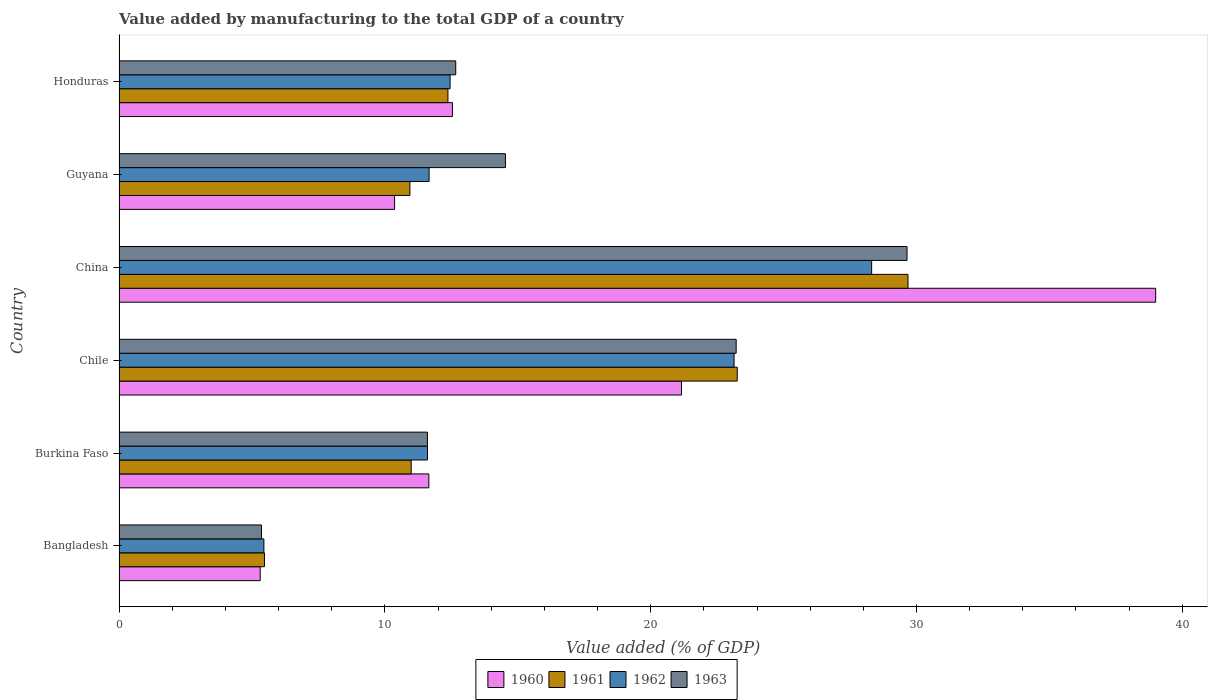How many different coloured bars are there?
Provide a succinct answer. 4. How many groups of bars are there?
Provide a short and direct response. 6. Are the number of bars per tick equal to the number of legend labels?
Offer a very short reply. Yes. Are the number of bars on each tick of the Y-axis equal?
Keep it short and to the point. Yes. How many bars are there on the 2nd tick from the top?
Give a very brief answer. 4. How many bars are there on the 2nd tick from the bottom?
Give a very brief answer. 4. What is the label of the 3rd group of bars from the top?
Offer a terse response. China. What is the value added by manufacturing to the total GDP in 1961 in Chile?
Provide a succinct answer. 23.26. Across all countries, what is the maximum value added by manufacturing to the total GDP in 1963?
Offer a very short reply. 29.64. Across all countries, what is the minimum value added by manufacturing to the total GDP in 1960?
Keep it short and to the point. 5.31. In which country was the value added by manufacturing to the total GDP in 1961 maximum?
Offer a terse response. China. What is the total value added by manufacturing to the total GDP in 1963 in the graph?
Your response must be concise. 97.02. What is the difference between the value added by manufacturing to the total GDP in 1960 in Burkina Faso and that in Chile?
Your response must be concise. -9.51. What is the difference between the value added by manufacturing to the total GDP in 1963 in Bangladesh and the value added by manufacturing to the total GDP in 1961 in China?
Offer a very short reply. -24.32. What is the average value added by manufacturing to the total GDP in 1963 per country?
Provide a succinct answer. 16.17. What is the difference between the value added by manufacturing to the total GDP in 1962 and value added by manufacturing to the total GDP in 1963 in Guyana?
Provide a short and direct response. -2.87. In how many countries, is the value added by manufacturing to the total GDP in 1961 greater than 24 %?
Ensure brevity in your answer.  1. What is the ratio of the value added by manufacturing to the total GDP in 1961 in China to that in Guyana?
Provide a short and direct response. 2.71. Is the value added by manufacturing to the total GDP in 1962 in Chile less than that in Guyana?
Offer a very short reply. No. Is the difference between the value added by manufacturing to the total GDP in 1962 in Guyana and Honduras greater than the difference between the value added by manufacturing to the total GDP in 1963 in Guyana and Honduras?
Keep it short and to the point. No. What is the difference between the highest and the second highest value added by manufacturing to the total GDP in 1963?
Your response must be concise. 6.43. What is the difference between the highest and the lowest value added by manufacturing to the total GDP in 1960?
Provide a succinct answer. 33.69. In how many countries, is the value added by manufacturing to the total GDP in 1963 greater than the average value added by manufacturing to the total GDP in 1963 taken over all countries?
Ensure brevity in your answer.  2. Is the sum of the value added by manufacturing to the total GDP in 1961 in Burkina Faso and Chile greater than the maximum value added by manufacturing to the total GDP in 1960 across all countries?
Provide a succinct answer. No. Is it the case that in every country, the sum of the value added by manufacturing to the total GDP in 1960 and value added by manufacturing to the total GDP in 1962 is greater than the sum of value added by manufacturing to the total GDP in 1963 and value added by manufacturing to the total GDP in 1961?
Keep it short and to the point. No. What does the 4th bar from the top in Bangladesh represents?
Offer a terse response. 1960. What does the 1st bar from the bottom in Bangladesh represents?
Provide a succinct answer. 1960. Is it the case that in every country, the sum of the value added by manufacturing to the total GDP in 1962 and value added by manufacturing to the total GDP in 1963 is greater than the value added by manufacturing to the total GDP in 1960?
Make the answer very short. Yes. How many bars are there?
Your response must be concise. 24. How many countries are there in the graph?
Make the answer very short. 6. What is the difference between two consecutive major ticks on the X-axis?
Provide a succinct answer. 10. Does the graph contain any zero values?
Ensure brevity in your answer.  No. Where does the legend appear in the graph?
Your answer should be very brief. Bottom center. What is the title of the graph?
Offer a terse response. Value added by manufacturing to the total GDP of a country. Does "1982" appear as one of the legend labels in the graph?
Your response must be concise. No. What is the label or title of the X-axis?
Make the answer very short. Value added (% of GDP). What is the label or title of the Y-axis?
Your answer should be very brief. Country. What is the Value added (% of GDP) of 1960 in Bangladesh?
Make the answer very short. 5.31. What is the Value added (% of GDP) in 1961 in Bangladesh?
Provide a short and direct response. 5.47. What is the Value added (% of GDP) in 1962 in Bangladesh?
Your answer should be compact. 5.45. What is the Value added (% of GDP) of 1963 in Bangladesh?
Give a very brief answer. 5.36. What is the Value added (% of GDP) in 1960 in Burkina Faso?
Keep it short and to the point. 11.65. What is the Value added (% of GDP) in 1961 in Burkina Faso?
Your response must be concise. 10.99. What is the Value added (% of GDP) of 1962 in Burkina Faso?
Make the answer very short. 11.6. What is the Value added (% of GDP) of 1963 in Burkina Faso?
Offer a terse response. 11.6. What is the Value added (% of GDP) in 1960 in Chile?
Ensure brevity in your answer.  21.16. What is the Value added (% of GDP) in 1961 in Chile?
Offer a terse response. 23.26. What is the Value added (% of GDP) in 1962 in Chile?
Make the answer very short. 23.14. What is the Value added (% of GDP) in 1963 in Chile?
Ensure brevity in your answer.  23.22. What is the Value added (% of GDP) in 1960 in China?
Give a very brief answer. 39. What is the Value added (% of GDP) of 1961 in China?
Provide a short and direct response. 29.68. What is the Value added (% of GDP) of 1962 in China?
Ensure brevity in your answer.  28.31. What is the Value added (% of GDP) in 1963 in China?
Ensure brevity in your answer.  29.64. What is the Value added (% of GDP) of 1960 in Guyana?
Make the answer very short. 10.37. What is the Value added (% of GDP) in 1961 in Guyana?
Ensure brevity in your answer.  10.94. What is the Value added (% of GDP) of 1962 in Guyana?
Keep it short and to the point. 11.66. What is the Value added (% of GDP) of 1963 in Guyana?
Keep it short and to the point. 14.54. What is the Value added (% of GDP) of 1960 in Honduras?
Your answer should be very brief. 12.54. What is the Value added (% of GDP) in 1961 in Honduras?
Your answer should be compact. 12.37. What is the Value added (% of GDP) of 1962 in Honduras?
Keep it short and to the point. 12.45. What is the Value added (% of GDP) of 1963 in Honduras?
Provide a short and direct response. 12.67. Across all countries, what is the maximum Value added (% of GDP) in 1960?
Offer a terse response. 39. Across all countries, what is the maximum Value added (% of GDP) of 1961?
Your response must be concise. 29.68. Across all countries, what is the maximum Value added (% of GDP) of 1962?
Keep it short and to the point. 28.31. Across all countries, what is the maximum Value added (% of GDP) in 1963?
Give a very brief answer. 29.64. Across all countries, what is the minimum Value added (% of GDP) of 1960?
Provide a short and direct response. 5.31. Across all countries, what is the minimum Value added (% of GDP) of 1961?
Offer a very short reply. 5.47. Across all countries, what is the minimum Value added (% of GDP) of 1962?
Offer a terse response. 5.45. Across all countries, what is the minimum Value added (% of GDP) of 1963?
Keep it short and to the point. 5.36. What is the total Value added (% of GDP) in 1960 in the graph?
Provide a short and direct response. 100.03. What is the total Value added (% of GDP) of 1961 in the graph?
Provide a succinct answer. 92.71. What is the total Value added (% of GDP) in 1962 in the graph?
Ensure brevity in your answer.  92.62. What is the total Value added (% of GDP) in 1963 in the graph?
Offer a terse response. 97.02. What is the difference between the Value added (% of GDP) in 1960 in Bangladesh and that in Burkina Faso?
Give a very brief answer. -6.34. What is the difference between the Value added (% of GDP) of 1961 in Bangladesh and that in Burkina Faso?
Your answer should be very brief. -5.52. What is the difference between the Value added (% of GDP) in 1962 in Bangladesh and that in Burkina Faso?
Provide a short and direct response. -6.16. What is the difference between the Value added (% of GDP) in 1963 in Bangladesh and that in Burkina Faso?
Make the answer very short. -6.24. What is the difference between the Value added (% of GDP) of 1960 in Bangladesh and that in Chile?
Offer a terse response. -15.85. What is the difference between the Value added (% of GDP) in 1961 in Bangladesh and that in Chile?
Provide a succinct answer. -17.79. What is the difference between the Value added (% of GDP) in 1962 in Bangladesh and that in Chile?
Ensure brevity in your answer.  -17.69. What is the difference between the Value added (% of GDP) of 1963 in Bangladesh and that in Chile?
Your answer should be compact. -17.86. What is the difference between the Value added (% of GDP) in 1960 in Bangladesh and that in China?
Your response must be concise. -33.69. What is the difference between the Value added (% of GDP) in 1961 in Bangladesh and that in China?
Offer a very short reply. -24.21. What is the difference between the Value added (% of GDP) of 1962 in Bangladesh and that in China?
Offer a terse response. -22.86. What is the difference between the Value added (% of GDP) in 1963 in Bangladesh and that in China?
Keep it short and to the point. -24.28. What is the difference between the Value added (% of GDP) in 1960 in Bangladesh and that in Guyana?
Make the answer very short. -5.06. What is the difference between the Value added (% of GDP) of 1961 in Bangladesh and that in Guyana?
Give a very brief answer. -5.47. What is the difference between the Value added (% of GDP) of 1962 in Bangladesh and that in Guyana?
Offer a terse response. -6.22. What is the difference between the Value added (% of GDP) of 1963 in Bangladesh and that in Guyana?
Provide a succinct answer. -9.18. What is the difference between the Value added (% of GDP) in 1960 in Bangladesh and that in Honduras?
Keep it short and to the point. -7.23. What is the difference between the Value added (% of GDP) of 1961 in Bangladesh and that in Honduras?
Make the answer very short. -6.9. What is the difference between the Value added (% of GDP) of 1962 in Bangladesh and that in Honduras?
Make the answer very short. -7.01. What is the difference between the Value added (% of GDP) of 1963 in Bangladesh and that in Honduras?
Your response must be concise. -7.31. What is the difference between the Value added (% of GDP) in 1960 in Burkina Faso and that in Chile?
Offer a terse response. -9.51. What is the difference between the Value added (% of GDP) of 1961 in Burkina Faso and that in Chile?
Your answer should be very brief. -12.27. What is the difference between the Value added (% of GDP) of 1962 in Burkina Faso and that in Chile?
Your response must be concise. -11.53. What is the difference between the Value added (% of GDP) in 1963 in Burkina Faso and that in Chile?
Your answer should be compact. -11.62. What is the difference between the Value added (% of GDP) of 1960 in Burkina Faso and that in China?
Give a very brief answer. -27.34. What is the difference between the Value added (% of GDP) in 1961 in Burkina Faso and that in China?
Keep it short and to the point. -18.69. What is the difference between the Value added (% of GDP) in 1962 in Burkina Faso and that in China?
Offer a very short reply. -16.71. What is the difference between the Value added (% of GDP) of 1963 in Burkina Faso and that in China?
Your answer should be very brief. -18.04. What is the difference between the Value added (% of GDP) of 1960 in Burkina Faso and that in Guyana?
Offer a terse response. 1.29. What is the difference between the Value added (% of GDP) of 1961 in Burkina Faso and that in Guyana?
Your answer should be very brief. 0.05. What is the difference between the Value added (% of GDP) of 1962 in Burkina Faso and that in Guyana?
Your response must be concise. -0.06. What is the difference between the Value added (% of GDP) of 1963 in Burkina Faso and that in Guyana?
Give a very brief answer. -2.94. What is the difference between the Value added (% of GDP) in 1960 in Burkina Faso and that in Honduras?
Offer a terse response. -0.89. What is the difference between the Value added (% of GDP) in 1961 in Burkina Faso and that in Honduras?
Your answer should be very brief. -1.38. What is the difference between the Value added (% of GDP) of 1962 in Burkina Faso and that in Honduras?
Keep it short and to the point. -0.85. What is the difference between the Value added (% of GDP) in 1963 in Burkina Faso and that in Honduras?
Make the answer very short. -1.07. What is the difference between the Value added (% of GDP) of 1960 in Chile and that in China?
Offer a very short reply. -17.84. What is the difference between the Value added (% of GDP) of 1961 in Chile and that in China?
Offer a terse response. -6.42. What is the difference between the Value added (% of GDP) in 1962 in Chile and that in China?
Provide a succinct answer. -5.17. What is the difference between the Value added (% of GDP) in 1963 in Chile and that in China?
Offer a very short reply. -6.43. What is the difference between the Value added (% of GDP) in 1960 in Chile and that in Guyana?
Give a very brief answer. 10.79. What is the difference between the Value added (% of GDP) in 1961 in Chile and that in Guyana?
Ensure brevity in your answer.  12.32. What is the difference between the Value added (% of GDP) of 1962 in Chile and that in Guyana?
Your answer should be compact. 11.47. What is the difference between the Value added (% of GDP) in 1963 in Chile and that in Guyana?
Provide a short and direct response. 8.68. What is the difference between the Value added (% of GDP) in 1960 in Chile and that in Honduras?
Provide a short and direct response. 8.62. What is the difference between the Value added (% of GDP) in 1961 in Chile and that in Honduras?
Give a very brief answer. 10.88. What is the difference between the Value added (% of GDP) in 1962 in Chile and that in Honduras?
Your response must be concise. 10.68. What is the difference between the Value added (% of GDP) in 1963 in Chile and that in Honduras?
Ensure brevity in your answer.  10.55. What is the difference between the Value added (% of GDP) in 1960 in China and that in Guyana?
Provide a succinct answer. 28.63. What is the difference between the Value added (% of GDP) of 1961 in China and that in Guyana?
Offer a terse response. 18.74. What is the difference between the Value added (% of GDP) in 1962 in China and that in Guyana?
Provide a short and direct response. 16.65. What is the difference between the Value added (% of GDP) in 1963 in China and that in Guyana?
Provide a succinct answer. 15.11. What is the difference between the Value added (% of GDP) in 1960 in China and that in Honduras?
Make the answer very short. 26.46. What is the difference between the Value added (% of GDP) in 1961 in China and that in Honduras?
Your response must be concise. 17.31. What is the difference between the Value added (% of GDP) in 1962 in China and that in Honduras?
Provide a succinct answer. 15.86. What is the difference between the Value added (% of GDP) of 1963 in China and that in Honduras?
Offer a very short reply. 16.98. What is the difference between the Value added (% of GDP) in 1960 in Guyana and that in Honduras?
Provide a short and direct response. -2.18. What is the difference between the Value added (% of GDP) in 1961 in Guyana and that in Honduras?
Your answer should be compact. -1.43. What is the difference between the Value added (% of GDP) in 1962 in Guyana and that in Honduras?
Your answer should be very brief. -0.79. What is the difference between the Value added (% of GDP) of 1963 in Guyana and that in Honduras?
Offer a very short reply. 1.87. What is the difference between the Value added (% of GDP) of 1960 in Bangladesh and the Value added (% of GDP) of 1961 in Burkina Faso?
Ensure brevity in your answer.  -5.68. What is the difference between the Value added (% of GDP) in 1960 in Bangladesh and the Value added (% of GDP) in 1962 in Burkina Faso?
Make the answer very short. -6.29. What is the difference between the Value added (% of GDP) of 1960 in Bangladesh and the Value added (% of GDP) of 1963 in Burkina Faso?
Ensure brevity in your answer.  -6.29. What is the difference between the Value added (% of GDP) of 1961 in Bangladesh and the Value added (% of GDP) of 1962 in Burkina Faso?
Provide a short and direct response. -6.13. What is the difference between the Value added (% of GDP) in 1961 in Bangladesh and the Value added (% of GDP) in 1963 in Burkina Faso?
Make the answer very short. -6.13. What is the difference between the Value added (% of GDP) in 1962 in Bangladesh and the Value added (% of GDP) in 1963 in Burkina Faso?
Provide a succinct answer. -6.15. What is the difference between the Value added (% of GDP) of 1960 in Bangladesh and the Value added (% of GDP) of 1961 in Chile?
Your answer should be very brief. -17.95. What is the difference between the Value added (% of GDP) of 1960 in Bangladesh and the Value added (% of GDP) of 1962 in Chile?
Provide a short and direct response. -17.83. What is the difference between the Value added (% of GDP) of 1960 in Bangladesh and the Value added (% of GDP) of 1963 in Chile?
Give a very brief answer. -17.91. What is the difference between the Value added (% of GDP) in 1961 in Bangladesh and the Value added (% of GDP) in 1962 in Chile?
Your answer should be compact. -17.67. What is the difference between the Value added (% of GDP) of 1961 in Bangladesh and the Value added (% of GDP) of 1963 in Chile?
Make the answer very short. -17.75. What is the difference between the Value added (% of GDP) in 1962 in Bangladesh and the Value added (% of GDP) in 1963 in Chile?
Ensure brevity in your answer.  -17.77. What is the difference between the Value added (% of GDP) in 1960 in Bangladesh and the Value added (% of GDP) in 1961 in China?
Provide a short and direct response. -24.37. What is the difference between the Value added (% of GDP) in 1960 in Bangladesh and the Value added (% of GDP) in 1962 in China?
Keep it short and to the point. -23. What is the difference between the Value added (% of GDP) of 1960 in Bangladesh and the Value added (% of GDP) of 1963 in China?
Offer a terse response. -24.33. What is the difference between the Value added (% of GDP) of 1961 in Bangladesh and the Value added (% of GDP) of 1962 in China?
Keep it short and to the point. -22.84. What is the difference between the Value added (% of GDP) of 1961 in Bangladesh and the Value added (% of GDP) of 1963 in China?
Ensure brevity in your answer.  -24.17. What is the difference between the Value added (% of GDP) of 1962 in Bangladesh and the Value added (% of GDP) of 1963 in China?
Your response must be concise. -24.2. What is the difference between the Value added (% of GDP) in 1960 in Bangladesh and the Value added (% of GDP) in 1961 in Guyana?
Ensure brevity in your answer.  -5.63. What is the difference between the Value added (% of GDP) of 1960 in Bangladesh and the Value added (% of GDP) of 1962 in Guyana?
Offer a very short reply. -6.35. What is the difference between the Value added (% of GDP) in 1960 in Bangladesh and the Value added (% of GDP) in 1963 in Guyana?
Provide a succinct answer. -9.23. What is the difference between the Value added (% of GDP) in 1961 in Bangladesh and the Value added (% of GDP) in 1962 in Guyana?
Provide a short and direct response. -6.19. What is the difference between the Value added (% of GDP) in 1961 in Bangladesh and the Value added (% of GDP) in 1963 in Guyana?
Your answer should be very brief. -9.07. What is the difference between the Value added (% of GDP) of 1962 in Bangladesh and the Value added (% of GDP) of 1963 in Guyana?
Give a very brief answer. -9.09. What is the difference between the Value added (% of GDP) in 1960 in Bangladesh and the Value added (% of GDP) in 1961 in Honduras?
Keep it short and to the point. -7.06. What is the difference between the Value added (% of GDP) in 1960 in Bangladesh and the Value added (% of GDP) in 1962 in Honduras?
Your response must be concise. -7.14. What is the difference between the Value added (% of GDP) in 1960 in Bangladesh and the Value added (% of GDP) in 1963 in Honduras?
Your answer should be very brief. -7.36. What is the difference between the Value added (% of GDP) in 1961 in Bangladesh and the Value added (% of GDP) in 1962 in Honduras?
Ensure brevity in your answer.  -6.98. What is the difference between the Value added (% of GDP) of 1961 in Bangladesh and the Value added (% of GDP) of 1963 in Honduras?
Your answer should be compact. -7.2. What is the difference between the Value added (% of GDP) of 1962 in Bangladesh and the Value added (% of GDP) of 1963 in Honduras?
Make the answer very short. -7.22. What is the difference between the Value added (% of GDP) of 1960 in Burkina Faso and the Value added (% of GDP) of 1961 in Chile?
Give a very brief answer. -11.6. What is the difference between the Value added (% of GDP) of 1960 in Burkina Faso and the Value added (% of GDP) of 1962 in Chile?
Your answer should be compact. -11.48. What is the difference between the Value added (% of GDP) of 1960 in Burkina Faso and the Value added (% of GDP) of 1963 in Chile?
Provide a short and direct response. -11.56. What is the difference between the Value added (% of GDP) in 1961 in Burkina Faso and the Value added (% of GDP) in 1962 in Chile?
Your answer should be very brief. -12.15. What is the difference between the Value added (% of GDP) of 1961 in Burkina Faso and the Value added (% of GDP) of 1963 in Chile?
Offer a terse response. -12.23. What is the difference between the Value added (% of GDP) of 1962 in Burkina Faso and the Value added (% of GDP) of 1963 in Chile?
Give a very brief answer. -11.61. What is the difference between the Value added (% of GDP) of 1960 in Burkina Faso and the Value added (% of GDP) of 1961 in China?
Make the answer very short. -18.03. What is the difference between the Value added (% of GDP) in 1960 in Burkina Faso and the Value added (% of GDP) in 1962 in China?
Provide a short and direct response. -16.66. What is the difference between the Value added (% of GDP) in 1960 in Burkina Faso and the Value added (% of GDP) in 1963 in China?
Your answer should be compact. -17.99. What is the difference between the Value added (% of GDP) in 1961 in Burkina Faso and the Value added (% of GDP) in 1962 in China?
Provide a succinct answer. -17.32. What is the difference between the Value added (% of GDP) in 1961 in Burkina Faso and the Value added (% of GDP) in 1963 in China?
Provide a short and direct response. -18.65. What is the difference between the Value added (% of GDP) in 1962 in Burkina Faso and the Value added (% of GDP) in 1963 in China?
Offer a terse response. -18.04. What is the difference between the Value added (% of GDP) of 1960 in Burkina Faso and the Value added (% of GDP) of 1961 in Guyana?
Offer a terse response. 0.71. What is the difference between the Value added (% of GDP) of 1960 in Burkina Faso and the Value added (% of GDP) of 1962 in Guyana?
Provide a succinct answer. -0.01. What is the difference between the Value added (% of GDP) in 1960 in Burkina Faso and the Value added (% of GDP) in 1963 in Guyana?
Make the answer very short. -2.88. What is the difference between the Value added (% of GDP) of 1961 in Burkina Faso and the Value added (% of GDP) of 1962 in Guyana?
Offer a terse response. -0.67. What is the difference between the Value added (% of GDP) in 1961 in Burkina Faso and the Value added (% of GDP) in 1963 in Guyana?
Provide a short and direct response. -3.55. What is the difference between the Value added (% of GDP) of 1962 in Burkina Faso and the Value added (% of GDP) of 1963 in Guyana?
Make the answer very short. -2.93. What is the difference between the Value added (% of GDP) of 1960 in Burkina Faso and the Value added (% of GDP) of 1961 in Honduras?
Give a very brief answer. -0.72. What is the difference between the Value added (% of GDP) of 1960 in Burkina Faso and the Value added (% of GDP) of 1962 in Honduras?
Your answer should be very brief. -0.8. What is the difference between the Value added (% of GDP) of 1960 in Burkina Faso and the Value added (% of GDP) of 1963 in Honduras?
Your response must be concise. -1.01. What is the difference between the Value added (% of GDP) in 1961 in Burkina Faso and the Value added (% of GDP) in 1962 in Honduras?
Offer a very short reply. -1.46. What is the difference between the Value added (% of GDP) in 1961 in Burkina Faso and the Value added (% of GDP) in 1963 in Honduras?
Make the answer very short. -1.68. What is the difference between the Value added (% of GDP) in 1962 in Burkina Faso and the Value added (% of GDP) in 1963 in Honduras?
Keep it short and to the point. -1.06. What is the difference between the Value added (% of GDP) of 1960 in Chile and the Value added (% of GDP) of 1961 in China?
Provide a succinct answer. -8.52. What is the difference between the Value added (% of GDP) of 1960 in Chile and the Value added (% of GDP) of 1962 in China?
Provide a short and direct response. -7.15. What is the difference between the Value added (% of GDP) in 1960 in Chile and the Value added (% of GDP) in 1963 in China?
Your answer should be compact. -8.48. What is the difference between the Value added (% of GDP) in 1961 in Chile and the Value added (% of GDP) in 1962 in China?
Provide a succinct answer. -5.06. What is the difference between the Value added (% of GDP) of 1961 in Chile and the Value added (% of GDP) of 1963 in China?
Offer a terse response. -6.39. What is the difference between the Value added (% of GDP) of 1962 in Chile and the Value added (% of GDP) of 1963 in China?
Your response must be concise. -6.51. What is the difference between the Value added (% of GDP) of 1960 in Chile and the Value added (% of GDP) of 1961 in Guyana?
Make the answer very short. 10.22. What is the difference between the Value added (% of GDP) in 1960 in Chile and the Value added (% of GDP) in 1962 in Guyana?
Your response must be concise. 9.5. What is the difference between the Value added (% of GDP) in 1960 in Chile and the Value added (% of GDP) in 1963 in Guyana?
Keep it short and to the point. 6.62. What is the difference between the Value added (% of GDP) of 1961 in Chile and the Value added (% of GDP) of 1962 in Guyana?
Keep it short and to the point. 11.59. What is the difference between the Value added (% of GDP) in 1961 in Chile and the Value added (% of GDP) in 1963 in Guyana?
Provide a short and direct response. 8.72. What is the difference between the Value added (% of GDP) in 1962 in Chile and the Value added (% of GDP) in 1963 in Guyana?
Offer a terse response. 8.6. What is the difference between the Value added (% of GDP) of 1960 in Chile and the Value added (% of GDP) of 1961 in Honduras?
Ensure brevity in your answer.  8.79. What is the difference between the Value added (% of GDP) in 1960 in Chile and the Value added (% of GDP) in 1962 in Honduras?
Your answer should be compact. 8.71. What is the difference between the Value added (% of GDP) in 1960 in Chile and the Value added (% of GDP) in 1963 in Honduras?
Make the answer very short. 8.49. What is the difference between the Value added (% of GDP) in 1961 in Chile and the Value added (% of GDP) in 1962 in Honduras?
Keep it short and to the point. 10.8. What is the difference between the Value added (% of GDP) in 1961 in Chile and the Value added (% of GDP) in 1963 in Honduras?
Make the answer very short. 10.59. What is the difference between the Value added (% of GDP) in 1962 in Chile and the Value added (% of GDP) in 1963 in Honduras?
Your answer should be very brief. 10.47. What is the difference between the Value added (% of GDP) of 1960 in China and the Value added (% of GDP) of 1961 in Guyana?
Your answer should be compact. 28.06. What is the difference between the Value added (% of GDP) of 1960 in China and the Value added (% of GDP) of 1962 in Guyana?
Ensure brevity in your answer.  27.33. What is the difference between the Value added (% of GDP) of 1960 in China and the Value added (% of GDP) of 1963 in Guyana?
Make the answer very short. 24.46. What is the difference between the Value added (% of GDP) in 1961 in China and the Value added (% of GDP) in 1962 in Guyana?
Your response must be concise. 18.02. What is the difference between the Value added (% of GDP) of 1961 in China and the Value added (% of GDP) of 1963 in Guyana?
Provide a succinct answer. 15.14. What is the difference between the Value added (% of GDP) of 1962 in China and the Value added (% of GDP) of 1963 in Guyana?
Your response must be concise. 13.78. What is the difference between the Value added (% of GDP) in 1960 in China and the Value added (% of GDP) in 1961 in Honduras?
Make the answer very short. 26.63. What is the difference between the Value added (% of GDP) in 1960 in China and the Value added (% of GDP) in 1962 in Honduras?
Keep it short and to the point. 26.54. What is the difference between the Value added (% of GDP) of 1960 in China and the Value added (% of GDP) of 1963 in Honduras?
Offer a very short reply. 26.33. What is the difference between the Value added (% of GDP) in 1961 in China and the Value added (% of GDP) in 1962 in Honduras?
Make the answer very short. 17.23. What is the difference between the Value added (% of GDP) of 1961 in China and the Value added (% of GDP) of 1963 in Honduras?
Your answer should be very brief. 17.01. What is the difference between the Value added (% of GDP) of 1962 in China and the Value added (% of GDP) of 1963 in Honduras?
Your answer should be compact. 15.65. What is the difference between the Value added (% of GDP) in 1960 in Guyana and the Value added (% of GDP) in 1961 in Honduras?
Provide a short and direct response. -2.01. What is the difference between the Value added (% of GDP) of 1960 in Guyana and the Value added (% of GDP) of 1962 in Honduras?
Your answer should be very brief. -2.09. What is the difference between the Value added (% of GDP) of 1960 in Guyana and the Value added (% of GDP) of 1963 in Honduras?
Provide a succinct answer. -2.3. What is the difference between the Value added (% of GDP) in 1961 in Guyana and the Value added (% of GDP) in 1962 in Honduras?
Provide a succinct answer. -1.51. What is the difference between the Value added (% of GDP) of 1961 in Guyana and the Value added (% of GDP) of 1963 in Honduras?
Your response must be concise. -1.73. What is the difference between the Value added (% of GDP) in 1962 in Guyana and the Value added (% of GDP) in 1963 in Honduras?
Your answer should be compact. -1. What is the average Value added (% of GDP) in 1960 per country?
Give a very brief answer. 16.67. What is the average Value added (% of GDP) of 1961 per country?
Your answer should be compact. 15.45. What is the average Value added (% of GDP) of 1962 per country?
Give a very brief answer. 15.44. What is the average Value added (% of GDP) in 1963 per country?
Offer a very short reply. 16.17. What is the difference between the Value added (% of GDP) of 1960 and Value added (% of GDP) of 1961 in Bangladesh?
Keep it short and to the point. -0.16. What is the difference between the Value added (% of GDP) in 1960 and Value added (% of GDP) in 1962 in Bangladesh?
Offer a terse response. -0.14. What is the difference between the Value added (% of GDP) of 1960 and Value added (% of GDP) of 1963 in Bangladesh?
Provide a succinct answer. -0.05. What is the difference between the Value added (% of GDP) of 1961 and Value added (% of GDP) of 1962 in Bangladesh?
Offer a very short reply. 0.02. What is the difference between the Value added (% of GDP) in 1961 and Value added (% of GDP) in 1963 in Bangladesh?
Provide a short and direct response. 0.11. What is the difference between the Value added (% of GDP) in 1962 and Value added (% of GDP) in 1963 in Bangladesh?
Ensure brevity in your answer.  0.09. What is the difference between the Value added (% of GDP) of 1960 and Value added (% of GDP) of 1961 in Burkina Faso?
Make the answer very short. 0.66. What is the difference between the Value added (% of GDP) in 1960 and Value added (% of GDP) in 1962 in Burkina Faso?
Offer a terse response. 0.05. What is the difference between the Value added (% of GDP) of 1960 and Value added (% of GDP) of 1963 in Burkina Faso?
Your answer should be very brief. 0.05. What is the difference between the Value added (% of GDP) in 1961 and Value added (% of GDP) in 1962 in Burkina Faso?
Your response must be concise. -0.61. What is the difference between the Value added (% of GDP) of 1961 and Value added (% of GDP) of 1963 in Burkina Faso?
Offer a terse response. -0.61. What is the difference between the Value added (% of GDP) in 1962 and Value added (% of GDP) in 1963 in Burkina Faso?
Offer a terse response. 0. What is the difference between the Value added (% of GDP) in 1960 and Value added (% of GDP) in 1961 in Chile?
Provide a short and direct response. -2.1. What is the difference between the Value added (% of GDP) in 1960 and Value added (% of GDP) in 1962 in Chile?
Offer a terse response. -1.98. What is the difference between the Value added (% of GDP) in 1960 and Value added (% of GDP) in 1963 in Chile?
Your answer should be compact. -2.06. What is the difference between the Value added (% of GDP) of 1961 and Value added (% of GDP) of 1962 in Chile?
Your answer should be compact. 0.12. What is the difference between the Value added (% of GDP) in 1961 and Value added (% of GDP) in 1963 in Chile?
Offer a terse response. 0.04. What is the difference between the Value added (% of GDP) in 1962 and Value added (% of GDP) in 1963 in Chile?
Give a very brief answer. -0.08. What is the difference between the Value added (% of GDP) of 1960 and Value added (% of GDP) of 1961 in China?
Keep it short and to the point. 9.32. What is the difference between the Value added (% of GDP) of 1960 and Value added (% of GDP) of 1962 in China?
Your answer should be very brief. 10.69. What is the difference between the Value added (% of GDP) in 1960 and Value added (% of GDP) in 1963 in China?
Keep it short and to the point. 9.35. What is the difference between the Value added (% of GDP) of 1961 and Value added (% of GDP) of 1962 in China?
Provide a short and direct response. 1.37. What is the difference between the Value added (% of GDP) in 1961 and Value added (% of GDP) in 1963 in China?
Make the answer very short. 0.04. What is the difference between the Value added (% of GDP) in 1962 and Value added (% of GDP) in 1963 in China?
Offer a very short reply. -1.33. What is the difference between the Value added (% of GDP) in 1960 and Value added (% of GDP) in 1961 in Guyana?
Your answer should be compact. -0.58. What is the difference between the Value added (% of GDP) of 1960 and Value added (% of GDP) of 1962 in Guyana?
Provide a succinct answer. -1.3. What is the difference between the Value added (% of GDP) of 1960 and Value added (% of GDP) of 1963 in Guyana?
Give a very brief answer. -4.17. What is the difference between the Value added (% of GDP) of 1961 and Value added (% of GDP) of 1962 in Guyana?
Your response must be concise. -0.72. What is the difference between the Value added (% of GDP) in 1961 and Value added (% of GDP) in 1963 in Guyana?
Ensure brevity in your answer.  -3.6. What is the difference between the Value added (% of GDP) in 1962 and Value added (% of GDP) in 1963 in Guyana?
Provide a short and direct response. -2.87. What is the difference between the Value added (% of GDP) of 1960 and Value added (% of GDP) of 1961 in Honduras?
Offer a terse response. 0.17. What is the difference between the Value added (% of GDP) of 1960 and Value added (% of GDP) of 1962 in Honduras?
Your answer should be very brief. 0.09. What is the difference between the Value added (% of GDP) in 1960 and Value added (% of GDP) in 1963 in Honduras?
Your response must be concise. -0.13. What is the difference between the Value added (% of GDP) in 1961 and Value added (% of GDP) in 1962 in Honduras?
Keep it short and to the point. -0.08. What is the difference between the Value added (% of GDP) in 1961 and Value added (% of GDP) in 1963 in Honduras?
Your answer should be very brief. -0.29. What is the difference between the Value added (% of GDP) of 1962 and Value added (% of GDP) of 1963 in Honduras?
Provide a short and direct response. -0.21. What is the ratio of the Value added (% of GDP) of 1960 in Bangladesh to that in Burkina Faso?
Ensure brevity in your answer.  0.46. What is the ratio of the Value added (% of GDP) of 1961 in Bangladesh to that in Burkina Faso?
Offer a terse response. 0.5. What is the ratio of the Value added (% of GDP) of 1962 in Bangladesh to that in Burkina Faso?
Provide a short and direct response. 0.47. What is the ratio of the Value added (% of GDP) in 1963 in Bangladesh to that in Burkina Faso?
Your answer should be very brief. 0.46. What is the ratio of the Value added (% of GDP) in 1960 in Bangladesh to that in Chile?
Your response must be concise. 0.25. What is the ratio of the Value added (% of GDP) in 1961 in Bangladesh to that in Chile?
Provide a succinct answer. 0.24. What is the ratio of the Value added (% of GDP) of 1962 in Bangladesh to that in Chile?
Provide a succinct answer. 0.24. What is the ratio of the Value added (% of GDP) in 1963 in Bangladesh to that in Chile?
Keep it short and to the point. 0.23. What is the ratio of the Value added (% of GDP) of 1960 in Bangladesh to that in China?
Keep it short and to the point. 0.14. What is the ratio of the Value added (% of GDP) in 1961 in Bangladesh to that in China?
Keep it short and to the point. 0.18. What is the ratio of the Value added (% of GDP) of 1962 in Bangladesh to that in China?
Your answer should be compact. 0.19. What is the ratio of the Value added (% of GDP) in 1963 in Bangladesh to that in China?
Your response must be concise. 0.18. What is the ratio of the Value added (% of GDP) of 1960 in Bangladesh to that in Guyana?
Your answer should be compact. 0.51. What is the ratio of the Value added (% of GDP) in 1961 in Bangladesh to that in Guyana?
Offer a very short reply. 0.5. What is the ratio of the Value added (% of GDP) in 1962 in Bangladesh to that in Guyana?
Give a very brief answer. 0.47. What is the ratio of the Value added (% of GDP) of 1963 in Bangladesh to that in Guyana?
Ensure brevity in your answer.  0.37. What is the ratio of the Value added (% of GDP) in 1960 in Bangladesh to that in Honduras?
Give a very brief answer. 0.42. What is the ratio of the Value added (% of GDP) of 1961 in Bangladesh to that in Honduras?
Your answer should be compact. 0.44. What is the ratio of the Value added (% of GDP) in 1962 in Bangladesh to that in Honduras?
Ensure brevity in your answer.  0.44. What is the ratio of the Value added (% of GDP) of 1963 in Bangladesh to that in Honduras?
Give a very brief answer. 0.42. What is the ratio of the Value added (% of GDP) of 1960 in Burkina Faso to that in Chile?
Ensure brevity in your answer.  0.55. What is the ratio of the Value added (% of GDP) in 1961 in Burkina Faso to that in Chile?
Your answer should be very brief. 0.47. What is the ratio of the Value added (% of GDP) of 1962 in Burkina Faso to that in Chile?
Provide a short and direct response. 0.5. What is the ratio of the Value added (% of GDP) in 1963 in Burkina Faso to that in Chile?
Offer a very short reply. 0.5. What is the ratio of the Value added (% of GDP) of 1960 in Burkina Faso to that in China?
Provide a succinct answer. 0.3. What is the ratio of the Value added (% of GDP) of 1961 in Burkina Faso to that in China?
Offer a very short reply. 0.37. What is the ratio of the Value added (% of GDP) in 1962 in Burkina Faso to that in China?
Your answer should be very brief. 0.41. What is the ratio of the Value added (% of GDP) of 1963 in Burkina Faso to that in China?
Your response must be concise. 0.39. What is the ratio of the Value added (% of GDP) in 1960 in Burkina Faso to that in Guyana?
Make the answer very short. 1.12. What is the ratio of the Value added (% of GDP) of 1961 in Burkina Faso to that in Guyana?
Provide a short and direct response. 1. What is the ratio of the Value added (% of GDP) of 1962 in Burkina Faso to that in Guyana?
Provide a succinct answer. 0.99. What is the ratio of the Value added (% of GDP) of 1963 in Burkina Faso to that in Guyana?
Your answer should be compact. 0.8. What is the ratio of the Value added (% of GDP) in 1960 in Burkina Faso to that in Honduras?
Your response must be concise. 0.93. What is the ratio of the Value added (% of GDP) of 1961 in Burkina Faso to that in Honduras?
Your answer should be compact. 0.89. What is the ratio of the Value added (% of GDP) of 1962 in Burkina Faso to that in Honduras?
Your answer should be very brief. 0.93. What is the ratio of the Value added (% of GDP) in 1963 in Burkina Faso to that in Honduras?
Ensure brevity in your answer.  0.92. What is the ratio of the Value added (% of GDP) in 1960 in Chile to that in China?
Give a very brief answer. 0.54. What is the ratio of the Value added (% of GDP) of 1961 in Chile to that in China?
Your answer should be compact. 0.78. What is the ratio of the Value added (% of GDP) of 1962 in Chile to that in China?
Provide a succinct answer. 0.82. What is the ratio of the Value added (% of GDP) in 1963 in Chile to that in China?
Offer a very short reply. 0.78. What is the ratio of the Value added (% of GDP) of 1960 in Chile to that in Guyana?
Provide a succinct answer. 2.04. What is the ratio of the Value added (% of GDP) of 1961 in Chile to that in Guyana?
Keep it short and to the point. 2.13. What is the ratio of the Value added (% of GDP) in 1962 in Chile to that in Guyana?
Your response must be concise. 1.98. What is the ratio of the Value added (% of GDP) of 1963 in Chile to that in Guyana?
Ensure brevity in your answer.  1.6. What is the ratio of the Value added (% of GDP) in 1960 in Chile to that in Honduras?
Your answer should be very brief. 1.69. What is the ratio of the Value added (% of GDP) in 1961 in Chile to that in Honduras?
Make the answer very short. 1.88. What is the ratio of the Value added (% of GDP) in 1962 in Chile to that in Honduras?
Provide a short and direct response. 1.86. What is the ratio of the Value added (% of GDP) of 1963 in Chile to that in Honduras?
Your response must be concise. 1.83. What is the ratio of the Value added (% of GDP) of 1960 in China to that in Guyana?
Provide a succinct answer. 3.76. What is the ratio of the Value added (% of GDP) in 1961 in China to that in Guyana?
Your response must be concise. 2.71. What is the ratio of the Value added (% of GDP) in 1962 in China to that in Guyana?
Provide a short and direct response. 2.43. What is the ratio of the Value added (% of GDP) of 1963 in China to that in Guyana?
Your answer should be very brief. 2.04. What is the ratio of the Value added (% of GDP) in 1960 in China to that in Honduras?
Offer a very short reply. 3.11. What is the ratio of the Value added (% of GDP) in 1961 in China to that in Honduras?
Offer a very short reply. 2.4. What is the ratio of the Value added (% of GDP) in 1962 in China to that in Honduras?
Give a very brief answer. 2.27. What is the ratio of the Value added (% of GDP) in 1963 in China to that in Honduras?
Your answer should be compact. 2.34. What is the ratio of the Value added (% of GDP) of 1960 in Guyana to that in Honduras?
Make the answer very short. 0.83. What is the ratio of the Value added (% of GDP) in 1961 in Guyana to that in Honduras?
Your answer should be compact. 0.88. What is the ratio of the Value added (% of GDP) in 1962 in Guyana to that in Honduras?
Keep it short and to the point. 0.94. What is the ratio of the Value added (% of GDP) in 1963 in Guyana to that in Honduras?
Keep it short and to the point. 1.15. What is the difference between the highest and the second highest Value added (% of GDP) of 1960?
Your answer should be very brief. 17.84. What is the difference between the highest and the second highest Value added (% of GDP) of 1961?
Offer a very short reply. 6.42. What is the difference between the highest and the second highest Value added (% of GDP) in 1962?
Provide a short and direct response. 5.17. What is the difference between the highest and the second highest Value added (% of GDP) of 1963?
Your response must be concise. 6.43. What is the difference between the highest and the lowest Value added (% of GDP) in 1960?
Offer a terse response. 33.69. What is the difference between the highest and the lowest Value added (% of GDP) in 1961?
Your response must be concise. 24.21. What is the difference between the highest and the lowest Value added (% of GDP) in 1962?
Offer a very short reply. 22.86. What is the difference between the highest and the lowest Value added (% of GDP) in 1963?
Your answer should be compact. 24.28. 